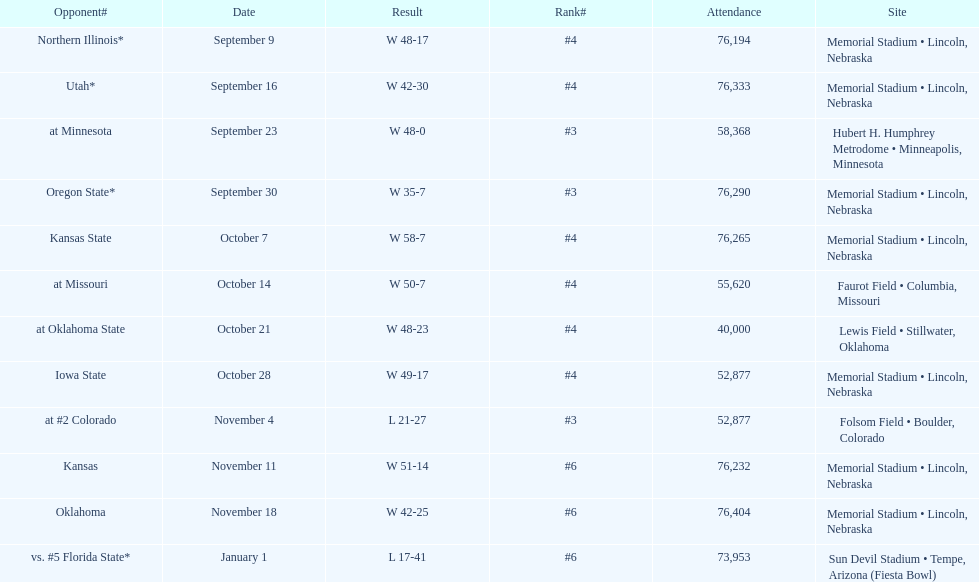How many matches did they win by over 7? 10. 